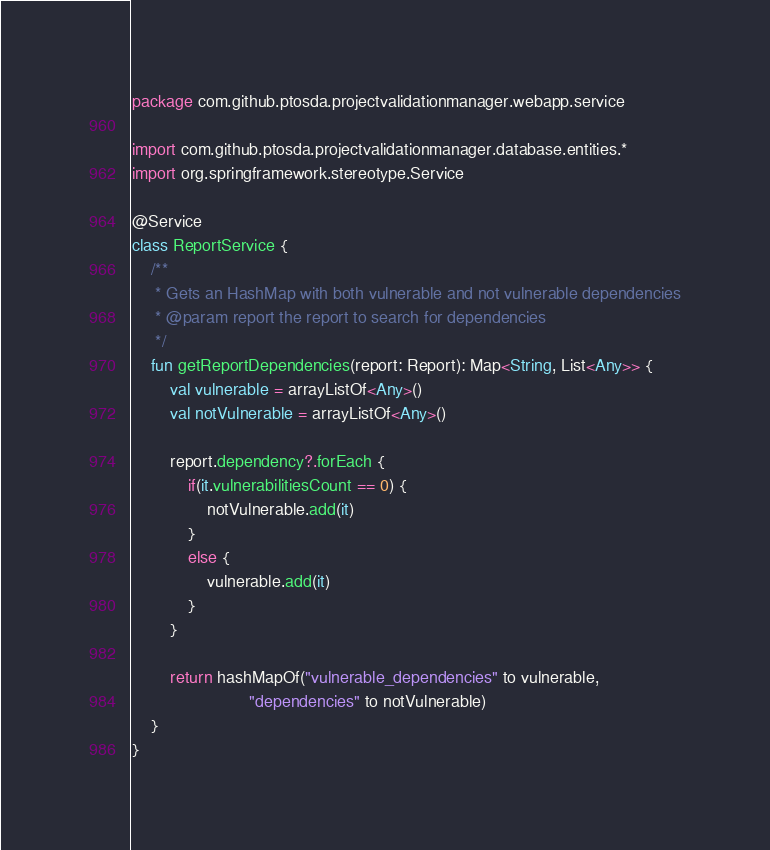<code> <loc_0><loc_0><loc_500><loc_500><_Kotlin_>package com.github.ptosda.projectvalidationmanager.webapp.service

import com.github.ptosda.projectvalidationmanager.database.entities.*
import org.springframework.stereotype.Service

@Service
class ReportService {
    /**
     * Gets an HashMap with both vulnerable and not vulnerable dependencies
     * @param report the report to search for dependencies
     */
    fun getReportDependencies(report: Report): Map<String, List<Any>> {
        val vulnerable = arrayListOf<Any>()
        val notVulnerable = arrayListOf<Any>()

        report.dependency?.forEach {
            if(it.vulnerabilitiesCount == 0) {
                notVulnerable.add(it)
            }
            else {
                vulnerable.add(it)
            }
        }

        return hashMapOf("vulnerable_dependencies" to vulnerable,
                         "dependencies" to notVulnerable)
    }
}</code> 